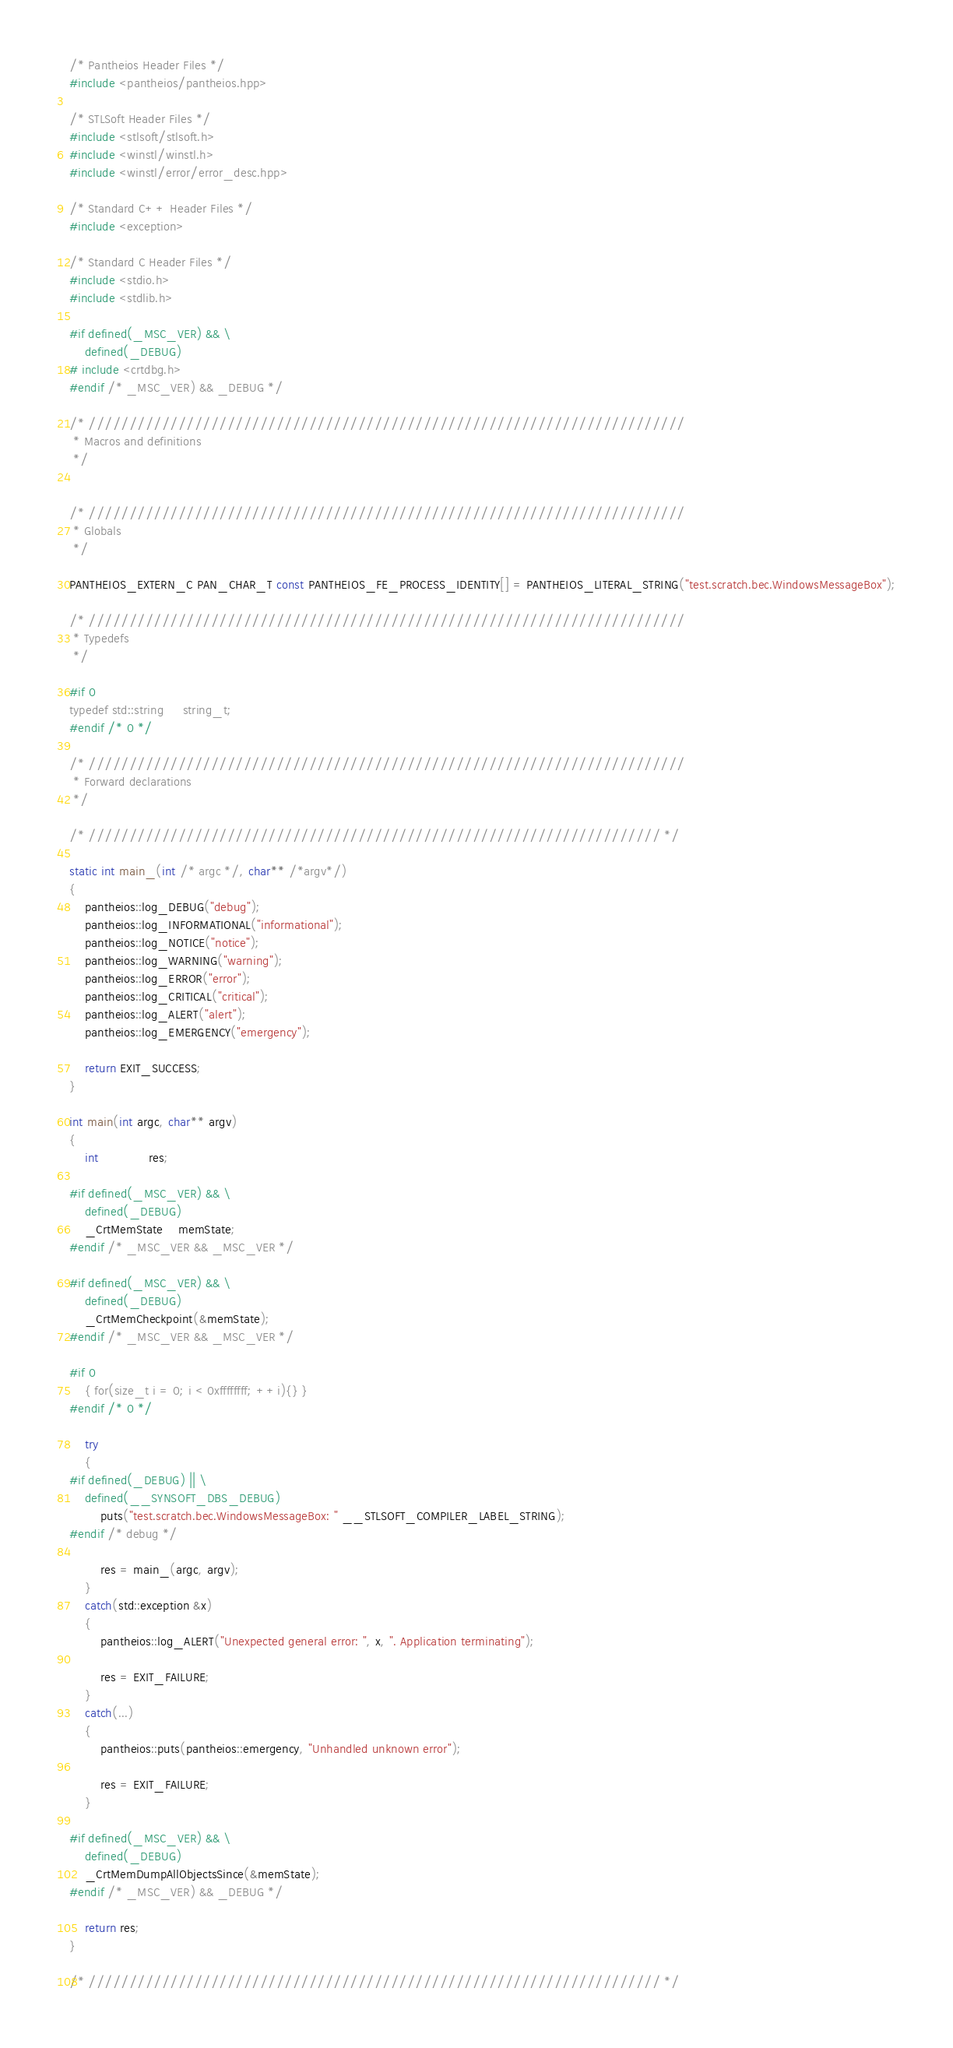<code> <loc_0><loc_0><loc_500><loc_500><_C++_>
/* Pantheios Header Files */
#include <pantheios/pantheios.hpp>

/* STLSoft Header Files */
#include <stlsoft/stlsoft.h>
#include <winstl/winstl.h>
#include <winstl/error/error_desc.hpp>

/* Standard C++ Header Files */
#include <exception>

/* Standard C Header Files */
#include <stdio.h>
#include <stdlib.h>

#if defined(_MSC_VER) && \
    defined(_DEBUG)
# include <crtdbg.h>
#endif /* _MSC_VER) && _DEBUG */

/* /////////////////////////////////////////////////////////////////////////
 * Macros and definitions
 */


/* /////////////////////////////////////////////////////////////////////////
 * Globals
 */

PANTHEIOS_EXTERN_C PAN_CHAR_T const PANTHEIOS_FE_PROCESS_IDENTITY[] = PANTHEIOS_LITERAL_STRING("test.scratch.bec.WindowsMessageBox");

/* /////////////////////////////////////////////////////////////////////////
 * Typedefs
 */

#if 0
typedef std::string     string_t;
#endif /* 0 */

/* /////////////////////////////////////////////////////////////////////////
 * Forward declarations
 */

/* ////////////////////////////////////////////////////////////////////// */

static int main_(int /* argc */, char** /*argv*/)
{
    pantheios::log_DEBUG("debug");
    pantheios::log_INFORMATIONAL("informational");
    pantheios::log_NOTICE("notice");
    pantheios::log_WARNING("warning");
    pantheios::log_ERROR("error");
    pantheios::log_CRITICAL("critical");
    pantheios::log_ALERT("alert");
    pantheios::log_EMERGENCY("emergency");

    return EXIT_SUCCESS;
}

int main(int argc, char** argv)
{
    int             res;

#if defined(_MSC_VER) && \
    defined(_DEBUG)
    _CrtMemState    memState;
#endif /* _MSC_VER && _MSC_VER */

#if defined(_MSC_VER) && \
    defined(_DEBUG)
    _CrtMemCheckpoint(&memState);
#endif /* _MSC_VER && _MSC_VER */

#if 0
    { for(size_t i = 0; i < 0xffffffff; ++i){} }
#endif /* 0 */

    try
    {
#if defined(_DEBUG) || \
    defined(__SYNSOFT_DBS_DEBUG)
        puts("test.scratch.bec.WindowsMessageBox: " __STLSOFT_COMPILER_LABEL_STRING);
#endif /* debug */

        res = main_(argc, argv);
    }
    catch(std::exception &x)
    {
        pantheios::log_ALERT("Unexpected general error: ", x, ". Application terminating");

        res = EXIT_FAILURE;
    }
    catch(...)
    {
        pantheios::puts(pantheios::emergency, "Unhandled unknown error");

        res = EXIT_FAILURE;
    }

#if defined(_MSC_VER) && \
    defined(_DEBUG)
    _CrtMemDumpAllObjectsSince(&memState);
#endif /* _MSC_VER) && _DEBUG */

    return res;
}

/* ////////////////////////////////////////////////////////////////////// */
</code> 